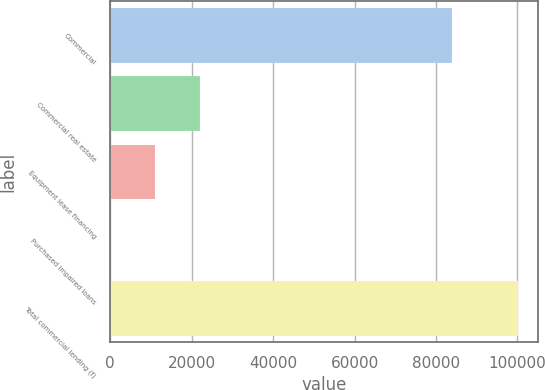<chart> <loc_0><loc_0><loc_500><loc_500><bar_chart><fcel>Commercial<fcel>Commercial real estate<fcel>Equipment lease financing<fcel>Purchased impaired loans<fcel>Total commercial lending (f)<nl><fcel>83903<fcel>22106.2<fcel>11058.1<fcel>10<fcel>100057<nl></chart> 